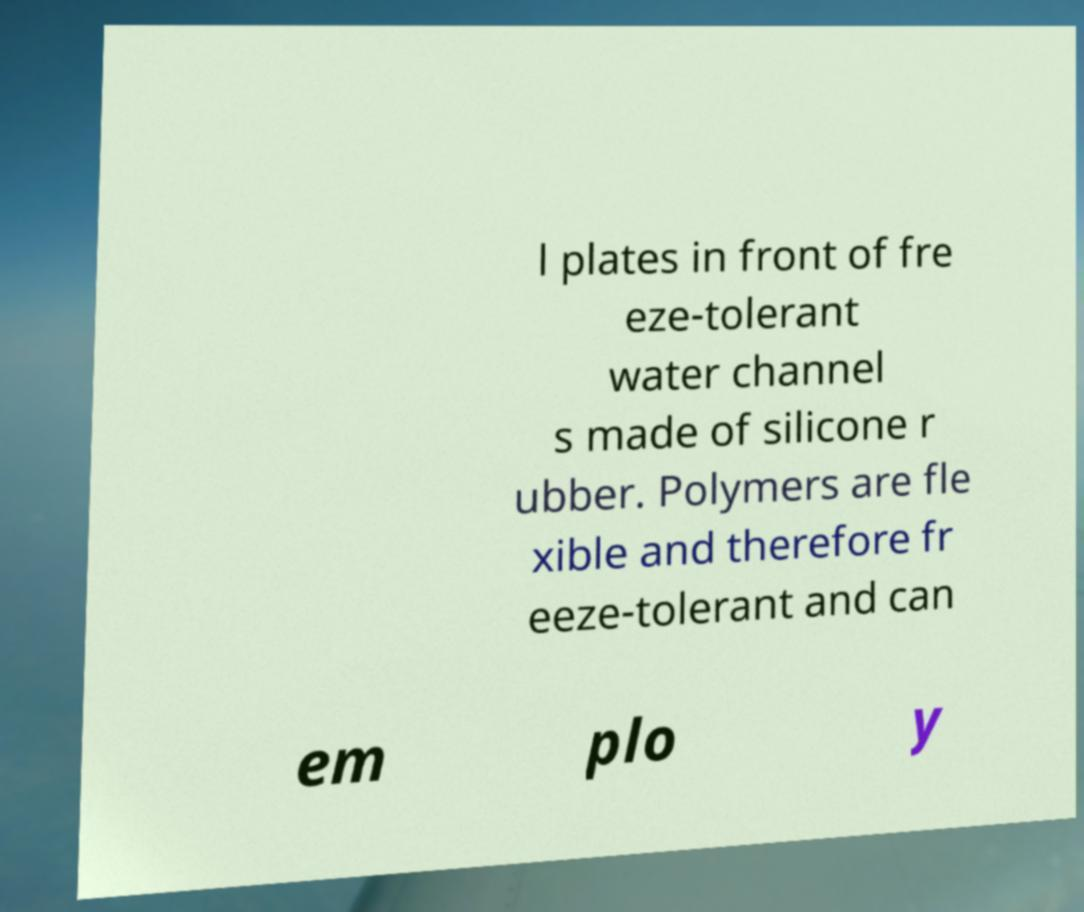Please read and relay the text visible in this image. What does it say? l plates in front of fre eze-tolerant water channel s made of silicone r ubber. Polymers are fle xible and therefore fr eeze-tolerant and can em plo y 